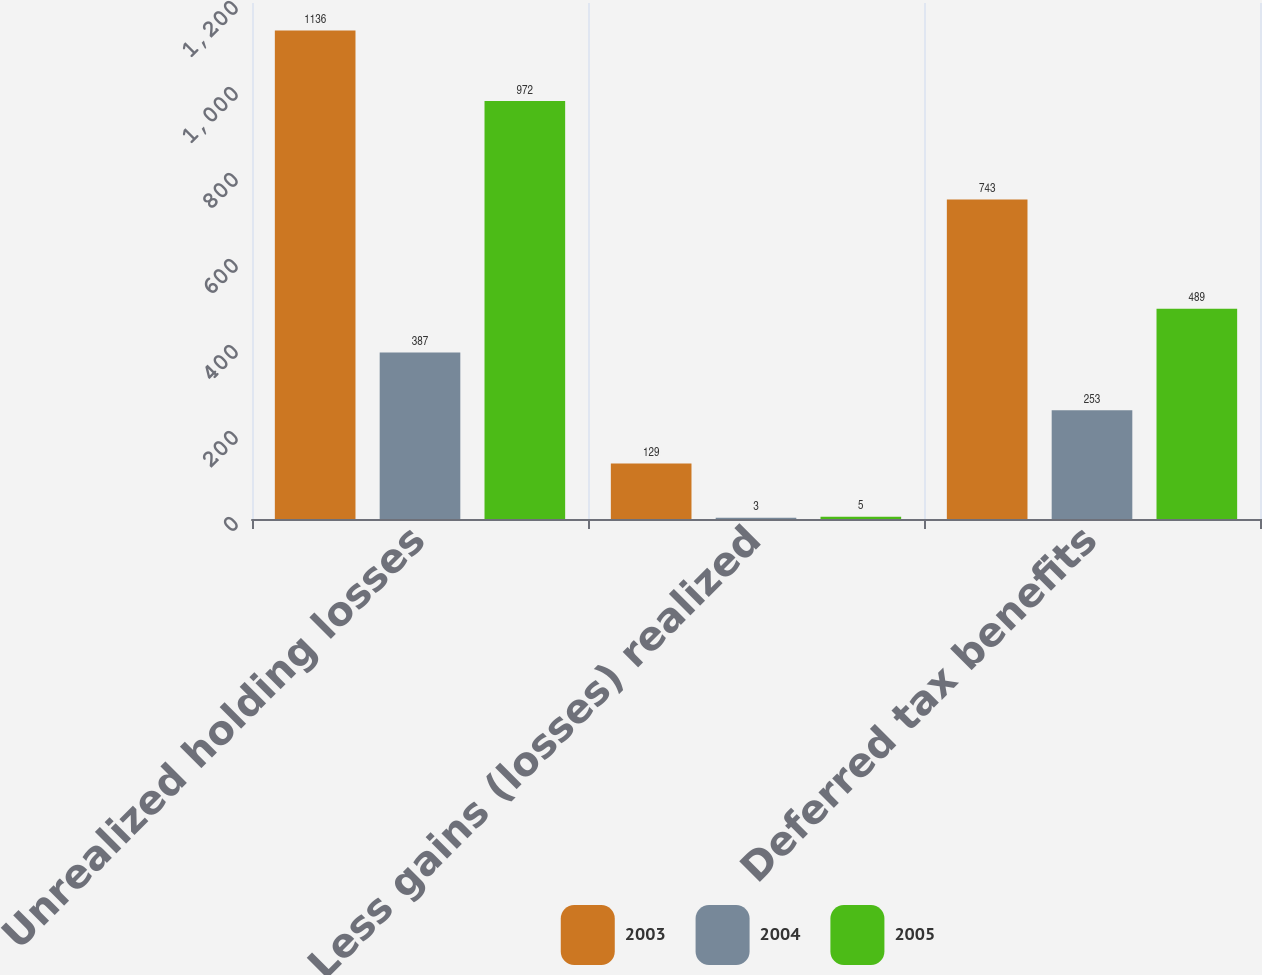Convert chart to OTSL. <chart><loc_0><loc_0><loc_500><loc_500><stacked_bar_chart><ecel><fcel>Unrealized holding losses<fcel>Less gains (losses) realized<fcel>Deferred tax benefits<nl><fcel>2003<fcel>1136<fcel>129<fcel>743<nl><fcel>2004<fcel>387<fcel>3<fcel>253<nl><fcel>2005<fcel>972<fcel>5<fcel>489<nl></chart> 